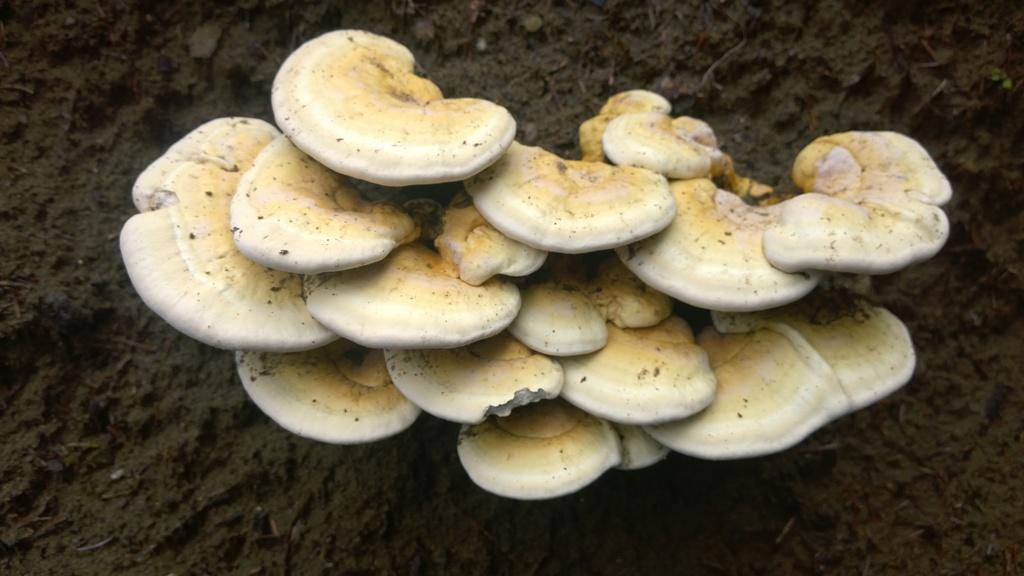In one or two sentences, can you explain what this image depicts? In this image in the center there are some mushrooms, and at the bottom three is sand. 